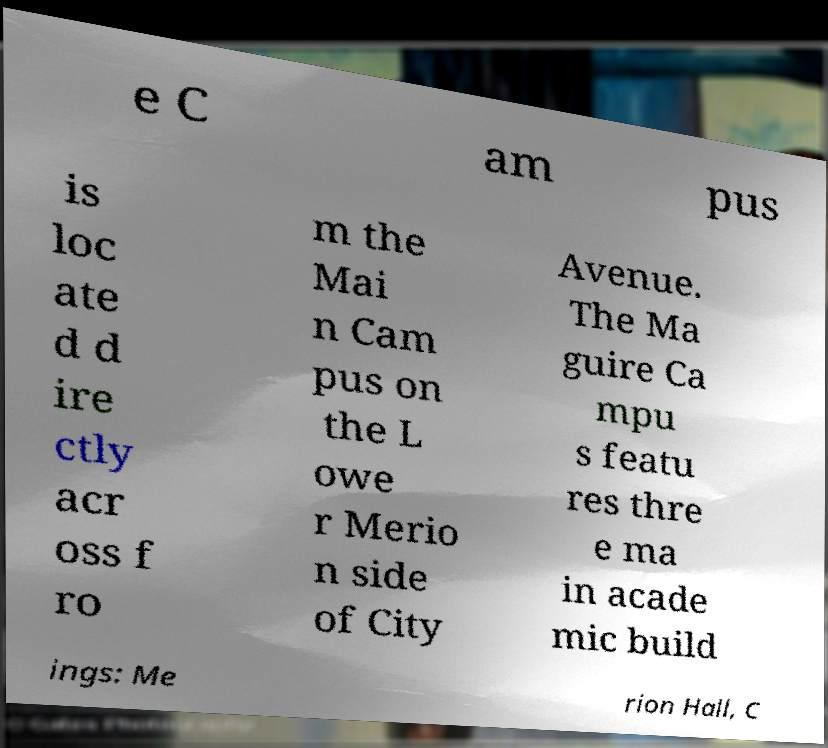Please read and relay the text visible in this image. What does it say? e C am pus is loc ate d d ire ctly acr oss f ro m the Mai n Cam pus on the L owe r Merio n side of City Avenue. The Ma guire Ca mpu s featu res thre e ma in acade mic build ings: Me rion Hall, C 